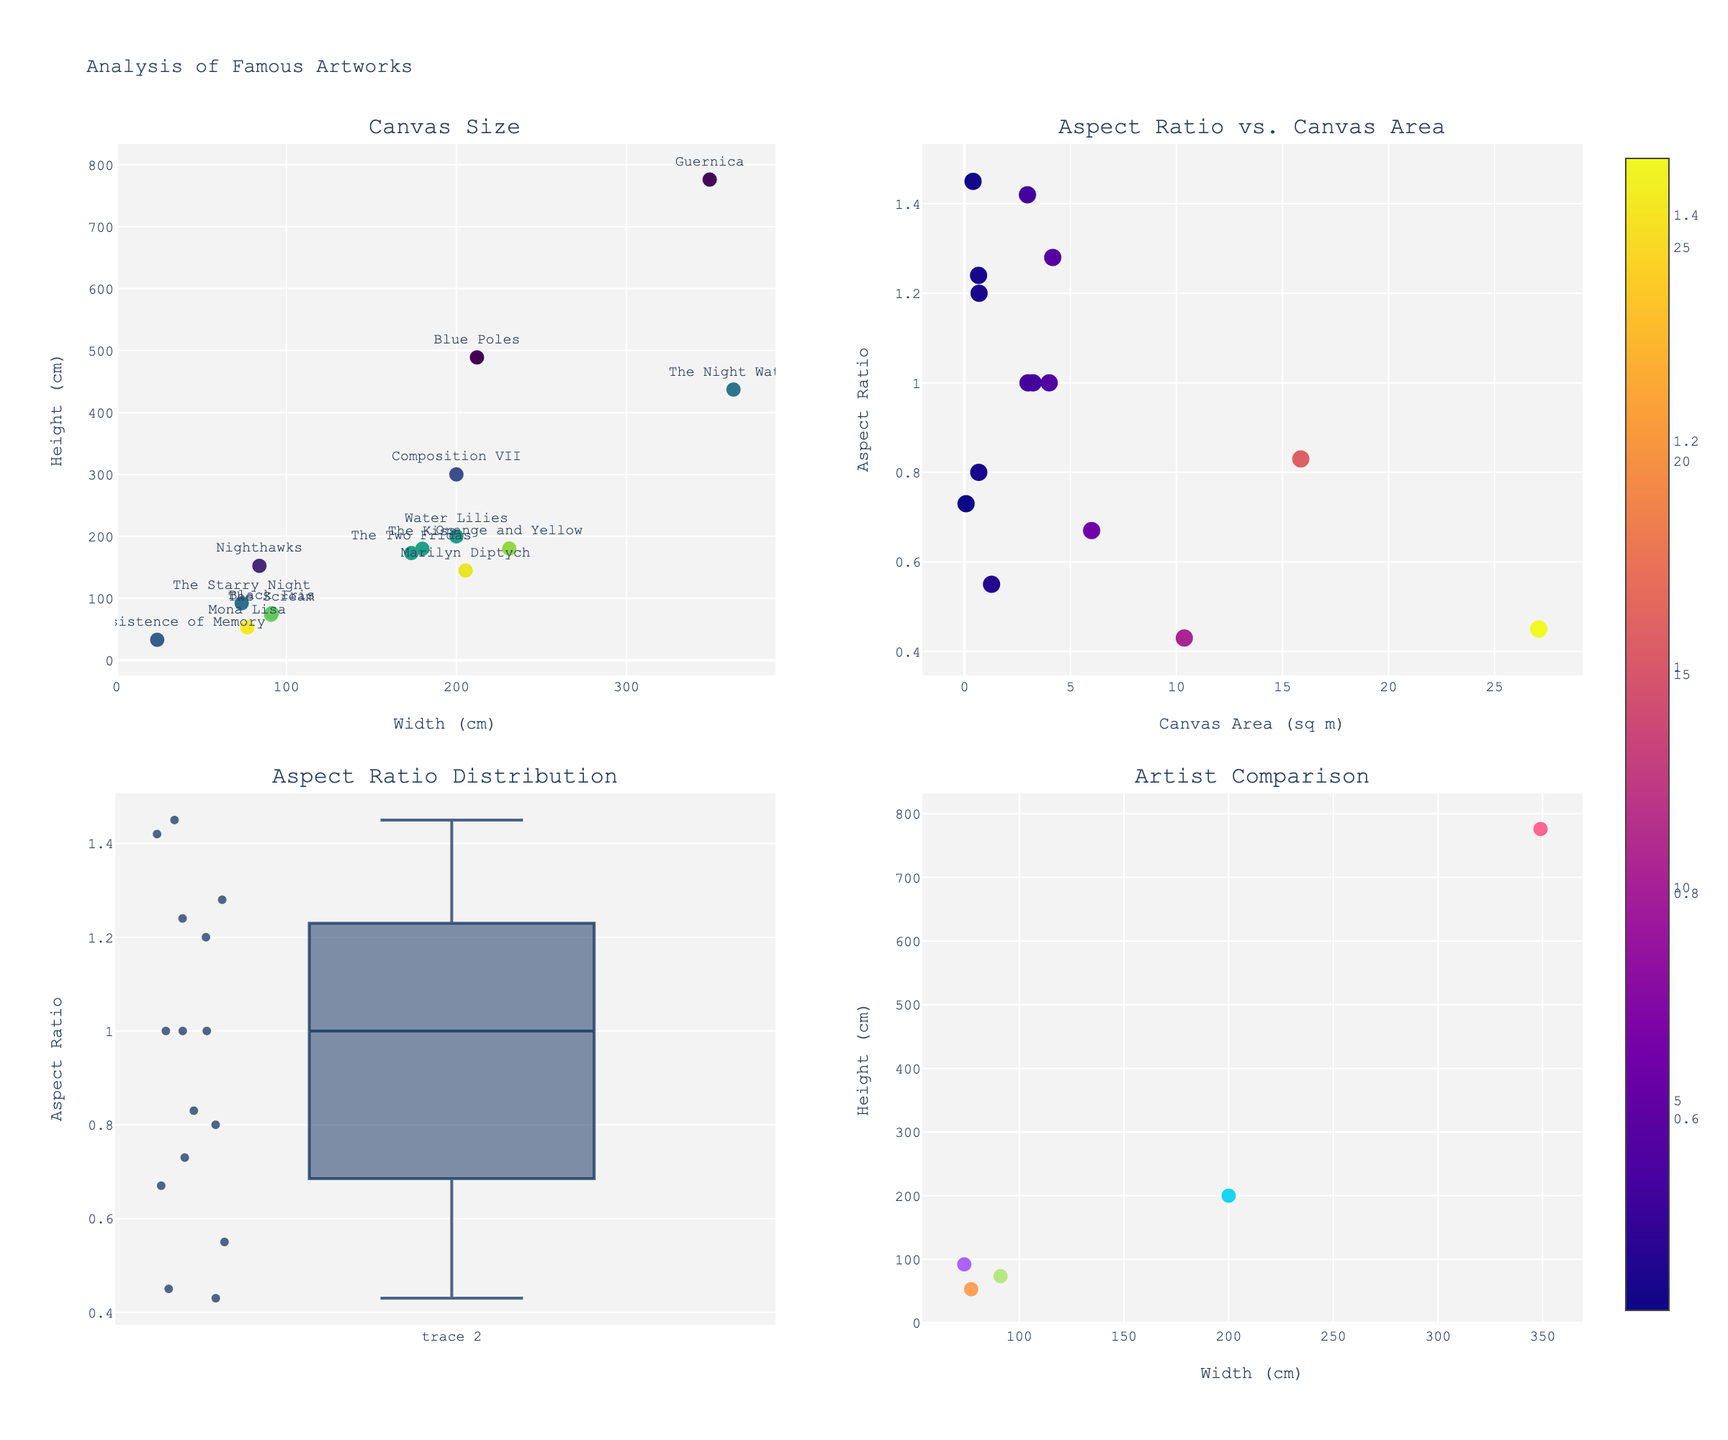What's the title of the figure? The title is displayed prominently at the top of the figure, summarizing the content of the plots.
Answer: Analysis of Famous Artworks Which artwork has the largest canvas area in square meters? By looking at the "Aspect Ratio vs. Canvas Area" scatter plot, we can identify the point with the highest x-value, then refer to the hover text to find the name of the artwork.
Answer: Guernica How many artworks have an aspect ratio of approximately 1.00? By examining the "Aspect Ratio Distribution" box plot, look for the individual points around the value of 1.00 on the y-axis and count them.
Answer: 3 Which two artworks have the closest aspect ratios? By examining the "Aspect Ratio Distribution" plot, identify two points that are very close together on the y-axis, and refer to the hover text for their names.
Answer: Water Lilies and The Kiss What is the width and height of 'The Starry Night'? Look at the "Canvas Size" scatter plot and hover over the point representing "The Starry Night" to see its width and height displayed in the hover text.
Answer: 73.7 cm (width), 92.1 cm (height) Which artist has the most artworks represented in the "Artist Comparison" subplot? By examining the "Artist Comparison" scatter plot, observe the legend or the number of markers corresponding to each artist.
Answer: None, all have one artwork Comparing "Nighthawks" and "Guernica", which has a smaller aspect ratio? Examine the "Aspect Ratio Distribution" plot and refer to the y-values of "Nighthawks" and "Guernica"; the one with the lower y-value has the smaller aspect ratio.
Answer: Guernica What is the median aspect ratio of the artworks? View the "Aspect Ratio Distribution" plot, where the median is represented by the horizontal line inside the box.
Answer: Approximately 1.00 Among "The Scream", "Black Iris", and "The Persistence of Memory", which has the largest canvas area? Refer to the "Aspect Ratio vs. Canvas Area" scatter plot, compare the x-values for these artworks, and see which has the highest x-value.
Answer: Black Iris Which artwork by Picasso has been included in the figure? Look for the hover text in any plot or the list in the "Artist Comparison" plot to find Picasso's represented artwork.
Answer: Guernica 